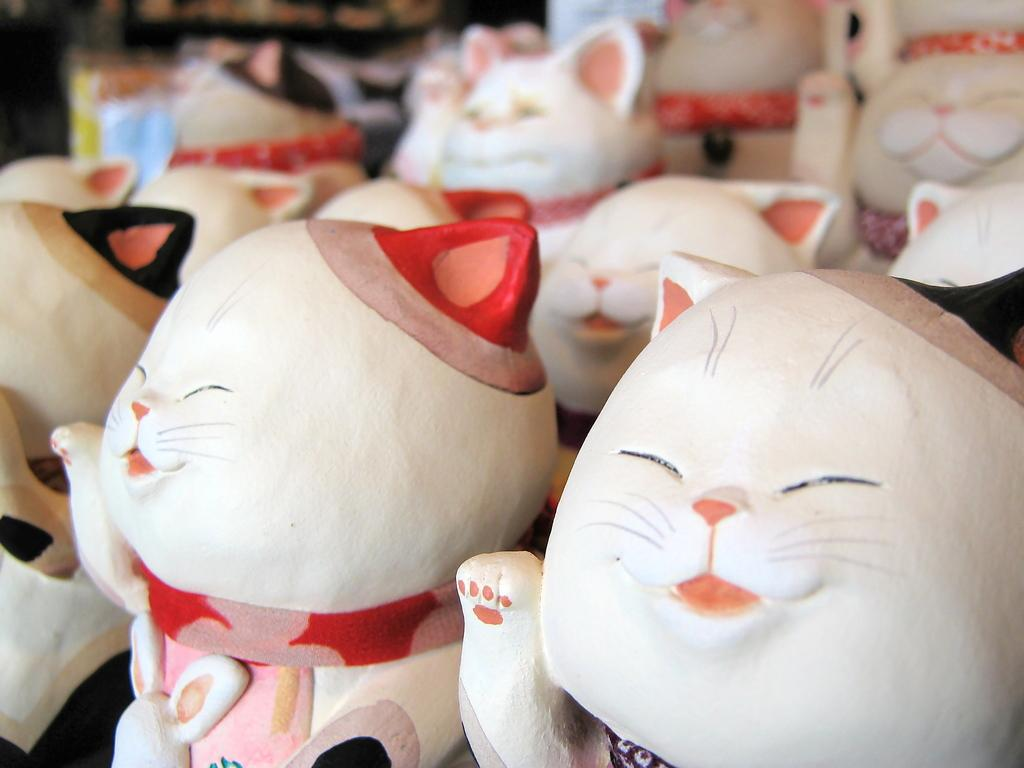What is the main subject of the image? The main subject of the image is a group of toys. Can you describe the toys in the image? Unfortunately, the facts provided do not give any specific details about the toys. Are there any other objects or figures in the image besides the toys? The facts provided do not mention any other objects or figures in the image. How many children are playing with the toys in the image? There are no children present in the image; it only features a group of toys. 